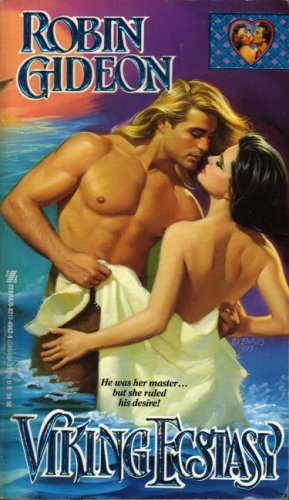Describe the mood or atmosphere conveyed by the book's cover. The cover conveys a dramatic and intense mood, with vivid colors and a close embrace between the characters, suggesting a passionate and emotionally charged narrative. 